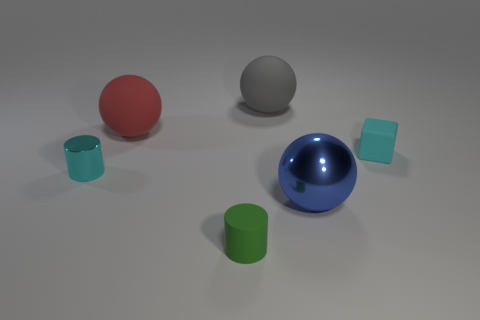Can you describe the different shapes present in this image and how many there are of each? Certainly! In the image, there are three spheres, two cylinders, and two cubes. The spheres include one large gray, one medium blue, and one small red. The cylinders are both green and identical in size. The cubes are both aqua-colored and also appear to be the same size. Could you guess the purpose of this arrangement? It seems like a visual exercise or a rendering to showcase various geometric shapes and colors, or perhaps a simple demonstration of 3D modeling. 